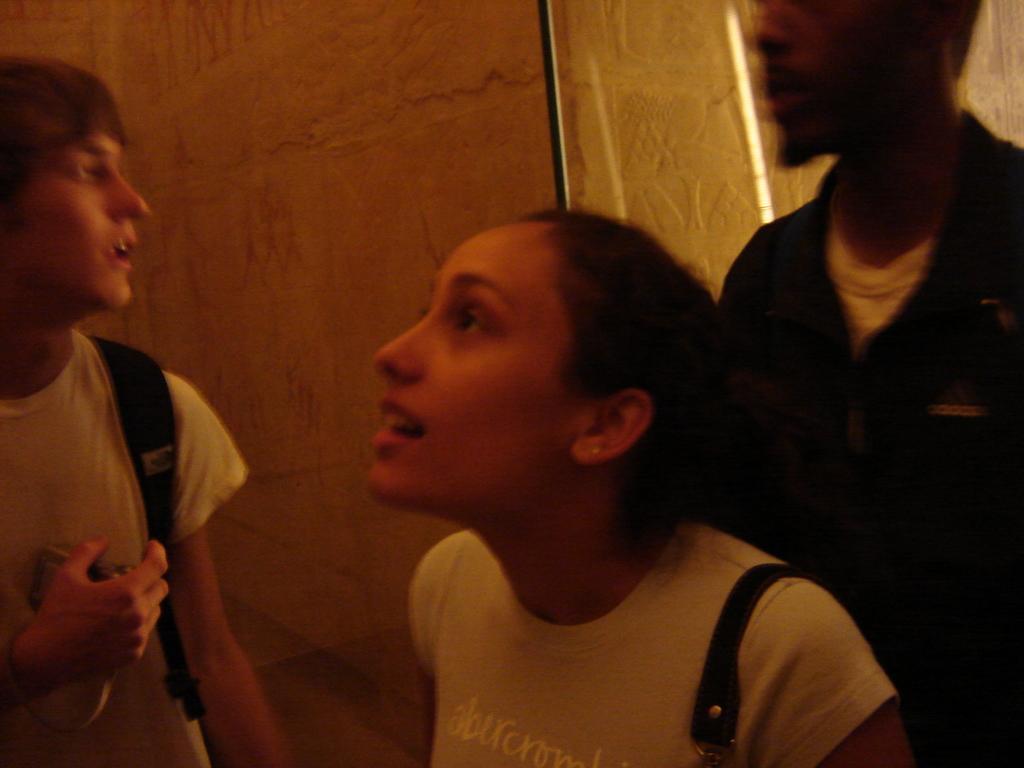Can you describe this image briefly? In this image we can see three people are standing, two persons wearing bags, one person holding object on the left side of the image, one object behind the woman in the middle of the image and it looks like a wall in the background. 